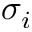Convert formula to latex. <formula><loc_0><loc_0><loc_500><loc_500>\sigma _ { i }</formula> 